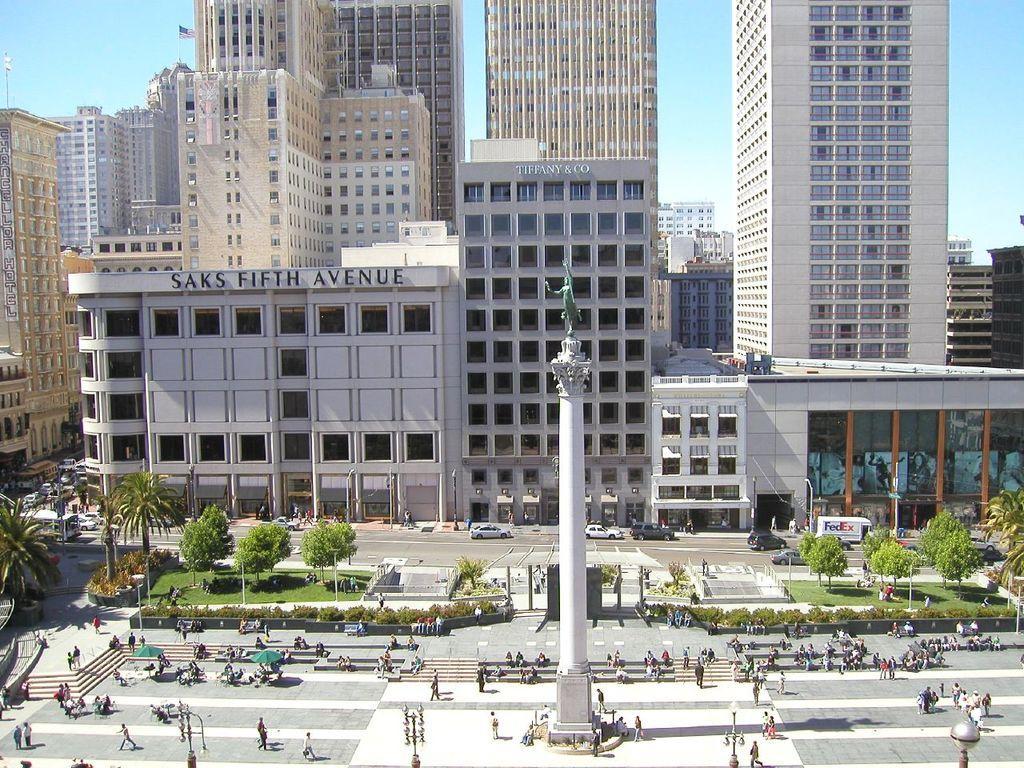How would you summarize this image in a sentence or two? In this image, we can see so many buildings, glass. At the bottom, there is a road, pillar, trees, plants, poles, shed, vehicles. Here we can see a group of people. Background there is a sky. 